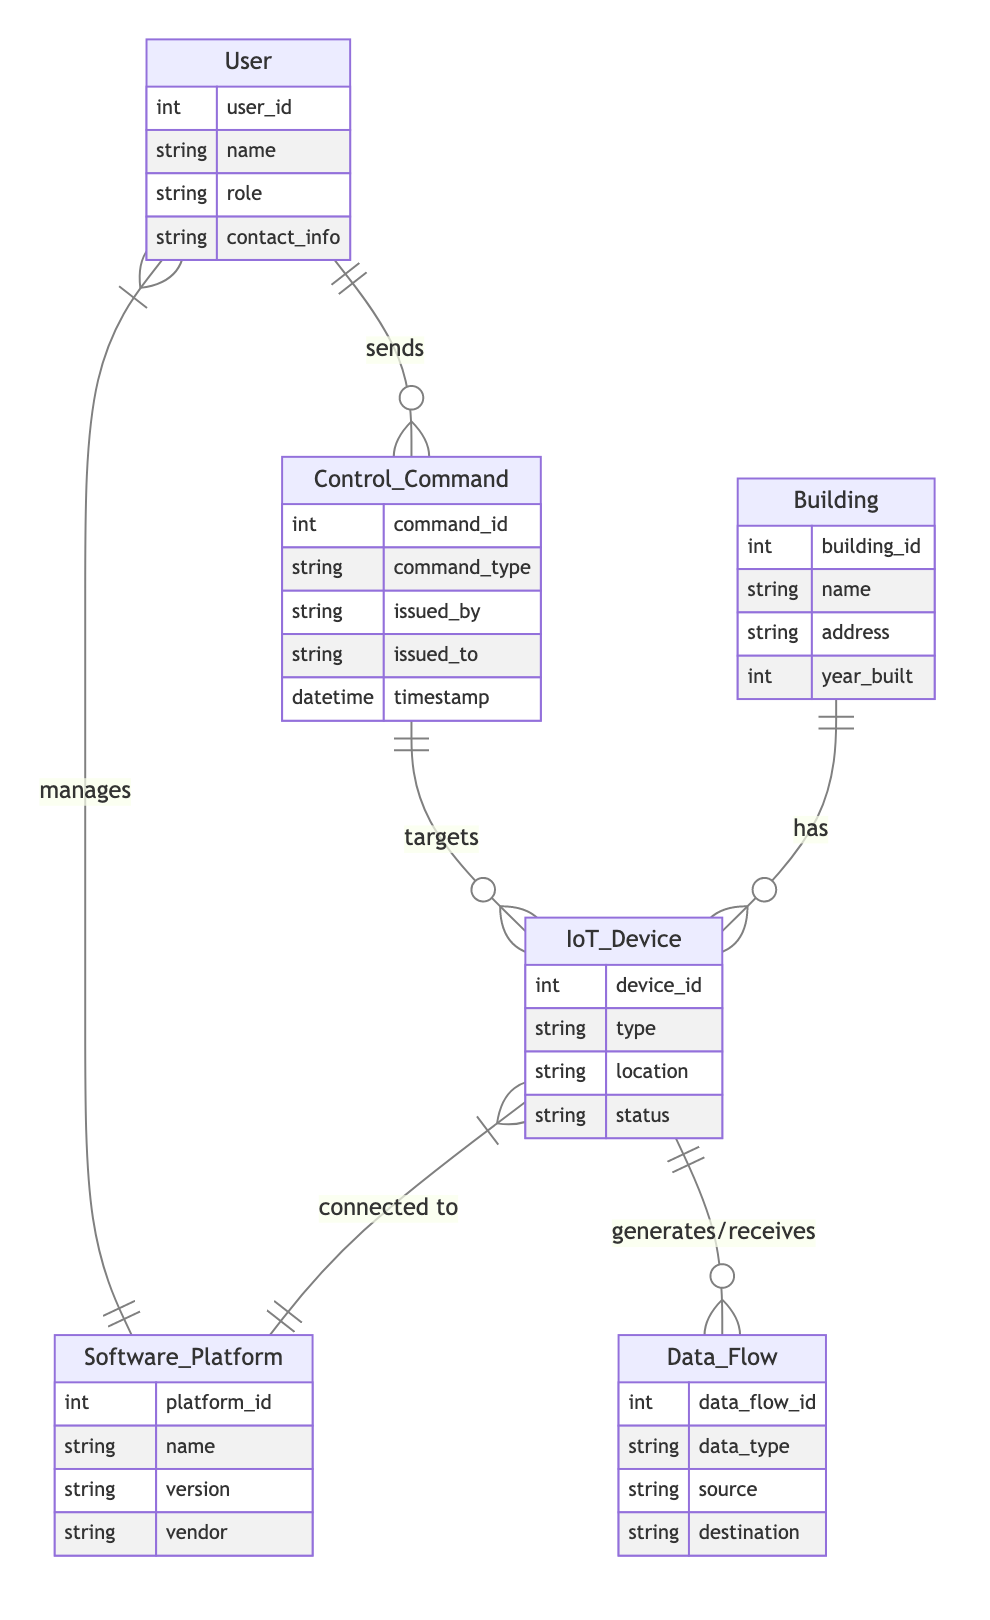What entities are involved in the diagram? The diagram includes six entities: Building, IoT_Device, Software_Platform, User, Data_Flow, and Control_Command. Each of these entities has specific attributes detailed in the diagram.
Answer: Building, IoT_Device, Software_Platform, User, Data_Flow, Control_Command How many relationships are shown in the diagram? The diagram outlines six relationships connecting the entities: Building has IoT_Device, IoT_Device connected to Software_Platform, User manages Software_Platform, IoT_Device generates/receives Data_Flow, User sends Control_Command, and Control_Command targets IoT_Device.
Answer: Six What is the relationship between User and Software_Platform? The relationship states that User manages Software_Platform, meaning there is an association where users have control or oversight over the software platforms.
Answer: Manages Which entity generates or receives data? The IoT_Device is the entity that generates or receives data as indicated by its relationship with the Data_Flow entity which shows its interactions.
Answer: IoT_Device What command type is associated with the Control_Command entity? The Control_Command entity has an attribute called command_type, which specifies the type of command issued in the system.
Answer: Command_type How many attributes does the Software_Platform entity have? The Software_Platform entity has four attributes: platform_id, name, version, and vendor, making a total of four attributes it contains.
Answer: Four What role do Users play in the system according to the diagram? Users are depicted as entities that send Control_Commands, suggesting their role is to interact with and give commands to the IoT devices through the software platforms.
Answer: Sends Which two entities are directly connected by the relationship "connected to"? The IoT_Device and Software_Platform are directly connected in the diagram by the relationship labeled "connected to", indicating their linkage in the technology integration process.
Answer: IoT_Device and Software_Platform What type of data flow is represented in the diagram? The data flow represented in the diagram includes Data_Flow between IoT_Device and other entities, indicating the communication and data transfer aspects of the system.
Answer: Data_Flow 